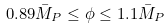Convert formula to latex. <formula><loc_0><loc_0><loc_500><loc_500>0 . 8 9 \bar { M } _ { P } \leq \phi \leq 1 . 1 \bar { M } _ { P }</formula> 